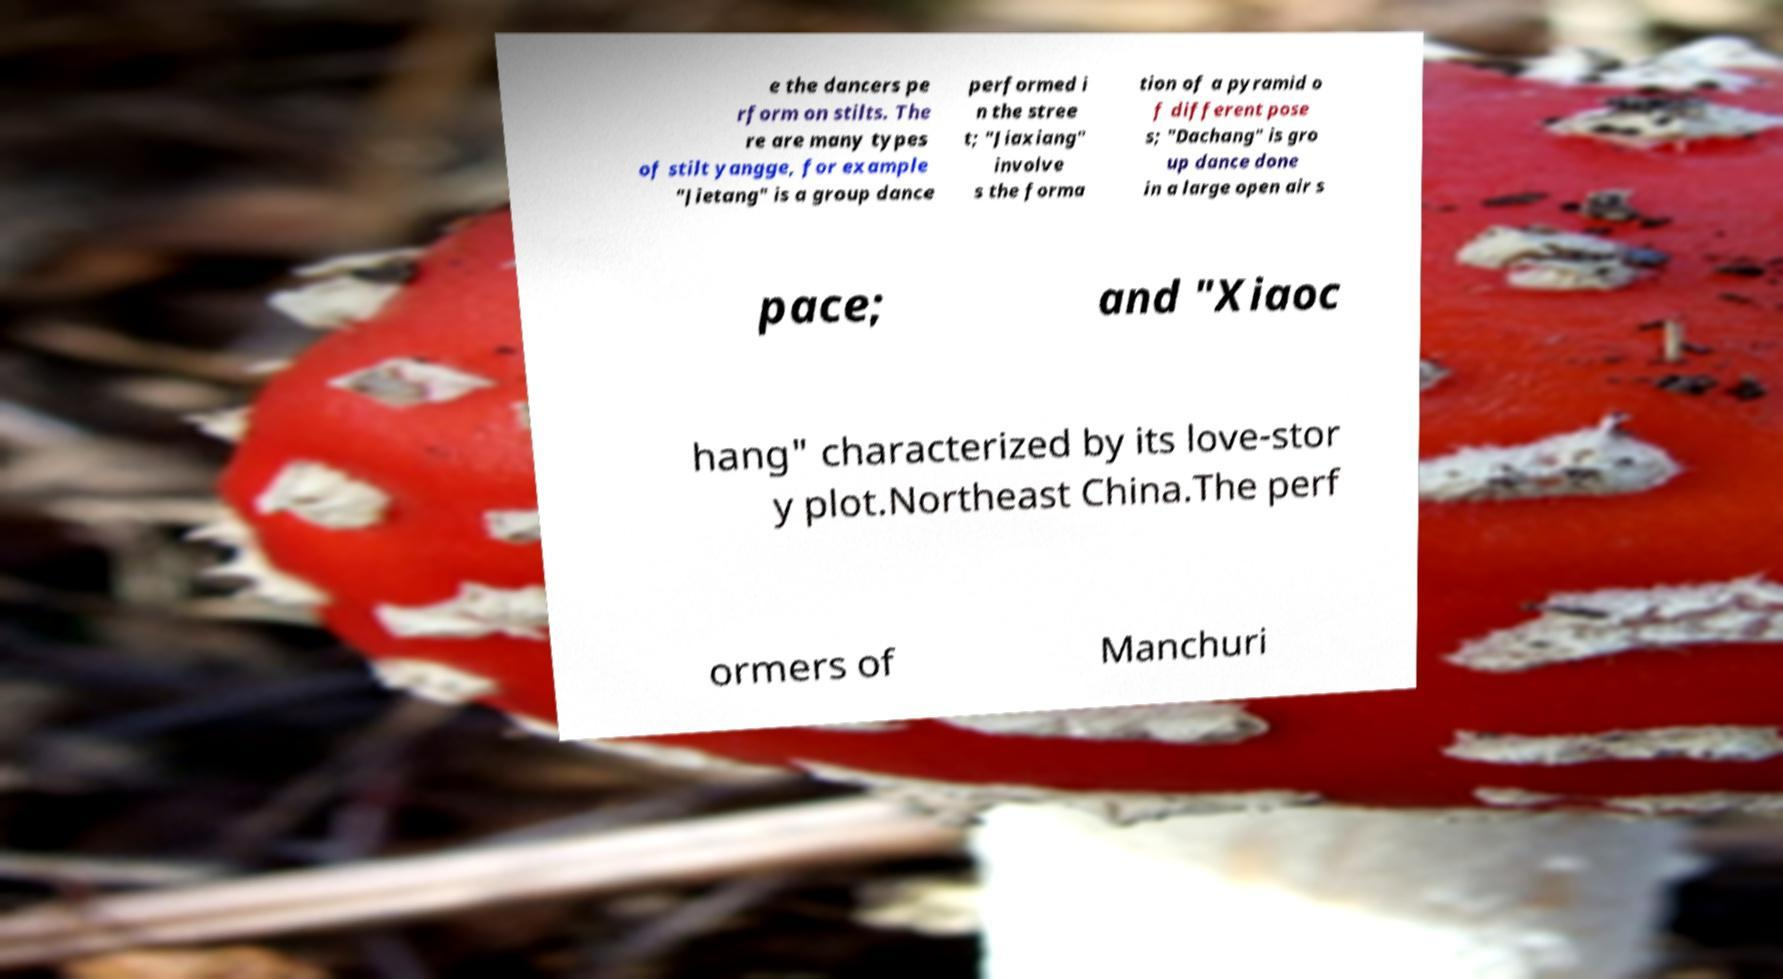Could you assist in decoding the text presented in this image and type it out clearly? e the dancers pe rform on stilts. The re are many types of stilt yangge, for example "Jietang" is a group dance performed i n the stree t; "Jiaxiang" involve s the forma tion of a pyramid o f different pose s; "Dachang" is gro up dance done in a large open air s pace; and "Xiaoc hang" characterized by its love-stor y plot.Northeast China.The perf ormers of Manchuri 